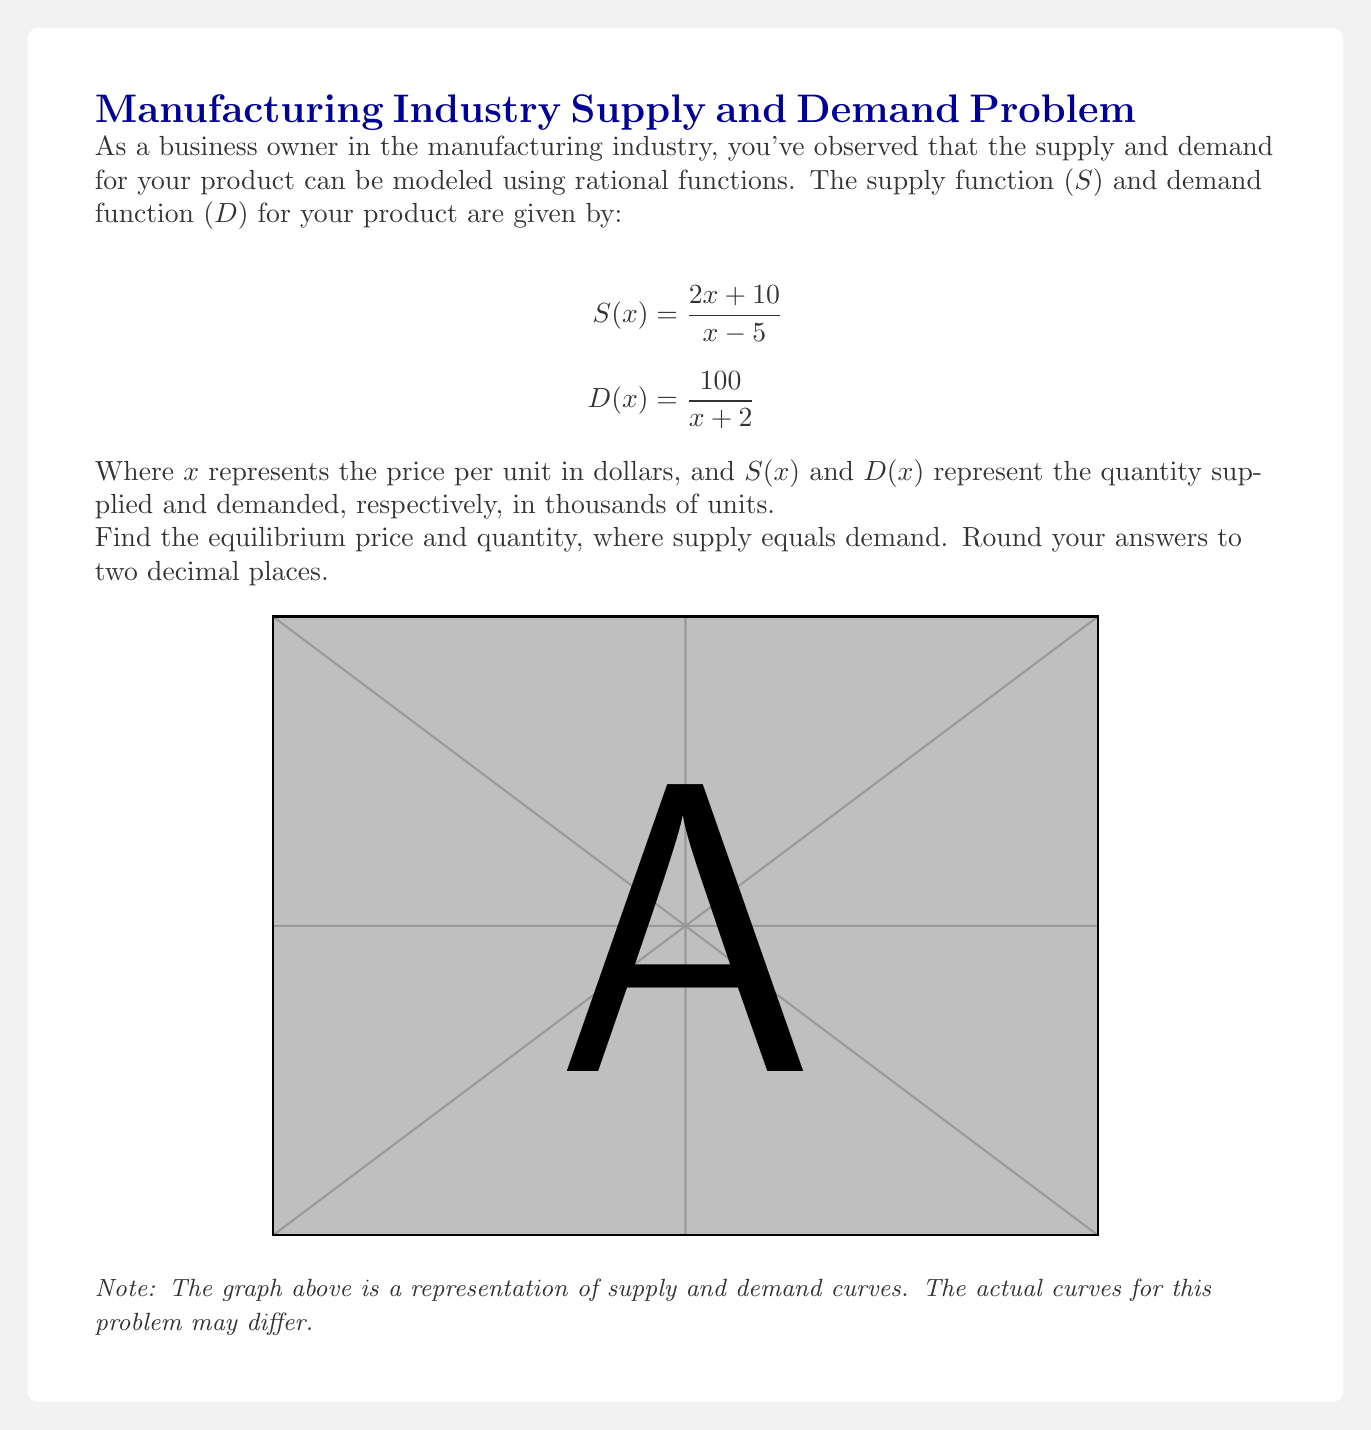What is the answer to this math problem? To find the equilibrium point, we need to set the supply and demand functions equal to each other:

$$S(x) = D(x)$$
$$\frac{2x+10}{x-5} = \frac{100}{x+2}$$

Now, let's solve this equation:

1) Cross-multiply to eliminate denominators:
   $$(2x+10)(x+2) = 100(x-5)$$

2) Expand the brackets:
   $$2x^2 + 4x + 10x + 20 = 100x - 500$$
   $$2x^2 + 14x + 20 = 100x - 500$$

3) Rearrange terms:
   $$2x^2 - 86x + 520 = 0$$

4) This is a quadratic equation. We can solve it using the quadratic formula:
   $$x = \frac{-b \pm \sqrt{b^2 - 4ac}}{2a}$$
   Where $a=2$, $b=-86$, and $c=520$

5) Plugging in these values:
   $$x = \frac{86 \pm \sqrt{(-86)^2 - 4(2)(520)}}{2(2)}$$
   $$x = \frac{86 \pm \sqrt{7396 - 4160}}{4}$$
   $$x = \frac{86 \pm \sqrt{3236}}{4}$$
   $$x = \frac{86 \pm 56.88}{4}$$

6) This gives us two solutions:
   $$x_1 = \frac{86 + 56.88}{4} = 35.72$$
   $$x_2 = \frac{86 - 56.88}{4} = 7.28$$

7) Since price cannot be negative, and 35.72 is beyond a reasonable price range for this scenario, we choose 7.28 as our equilibrium price.

8) To find the equilibrium quantity, we can substitute this price into either the supply or demand function. Let's use the demand function:

   $$D(7.28) = \frac{100}{7.28+2} = \frac{100}{9.28} \approx 10.78$$

Therefore, the equilibrium price is approximately $7.28 per unit, and the equilibrium quantity is approximately 10.78 thousand units.
Answer: Price: $7.28, Quantity: 10.78 thousand units 